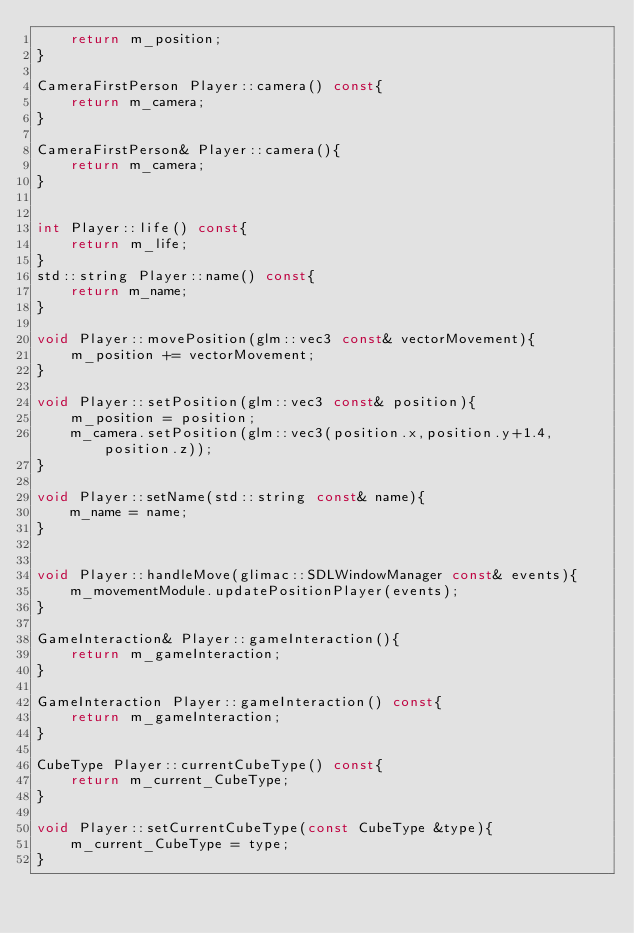Convert code to text. <code><loc_0><loc_0><loc_500><loc_500><_C++_>    return m_position;
}

CameraFirstPerson Player::camera() const{
    return m_camera;
}

CameraFirstPerson& Player::camera(){
    return m_camera;
}


int Player::life() const{
    return m_life;
}
std::string Player::name() const{
    return m_name;
}

void Player::movePosition(glm::vec3 const& vectorMovement){
    m_position += vectorMovement;
}

void Player::setPosition(glm::vec3 const& position){
    m_position = position;
    m_camera.setPosition(glm::vec3(position.x,position.y+1.4, position.z));
}

void Player::setName(std::string const& name){
    m_name = name;
}


void Player::handleMove(glimac::SDLWindowManager const& events){
    m_movementModule.updatePositionPlayer(events);
}

GameInteraction& Player::gameInteraction(){
    return m_gameInteraction;
}

GameInteraction Player::gameInteraction() const{
    return m_gameInteraction;
}

CubeType Player::currentCubeType() const{
    return m_current_CubeType;
}

void Player::setCurrentCubeType(const CubeType &type){
    m_current_CubeType = type;
}
</code> 